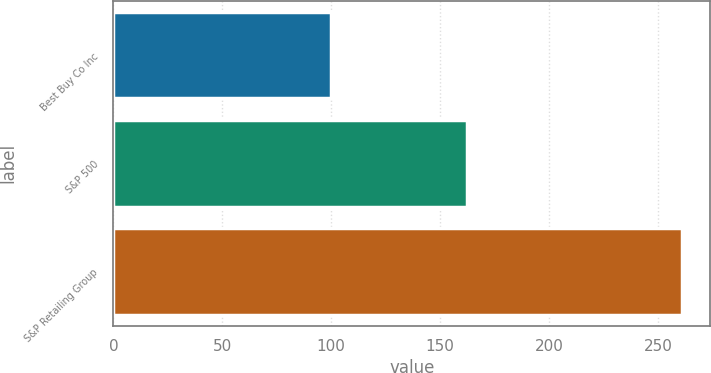Convert chart to OTSL. <chart><loc_0><loc_0><loc_500><loc_500><bar_chart><fcel>Best Buy Co Inc<fcel>S&P 500<fcel>S&P Retailing Group<nl><fcel>99.87<fcel>162.25<fcel>261.07<nl></chart> 